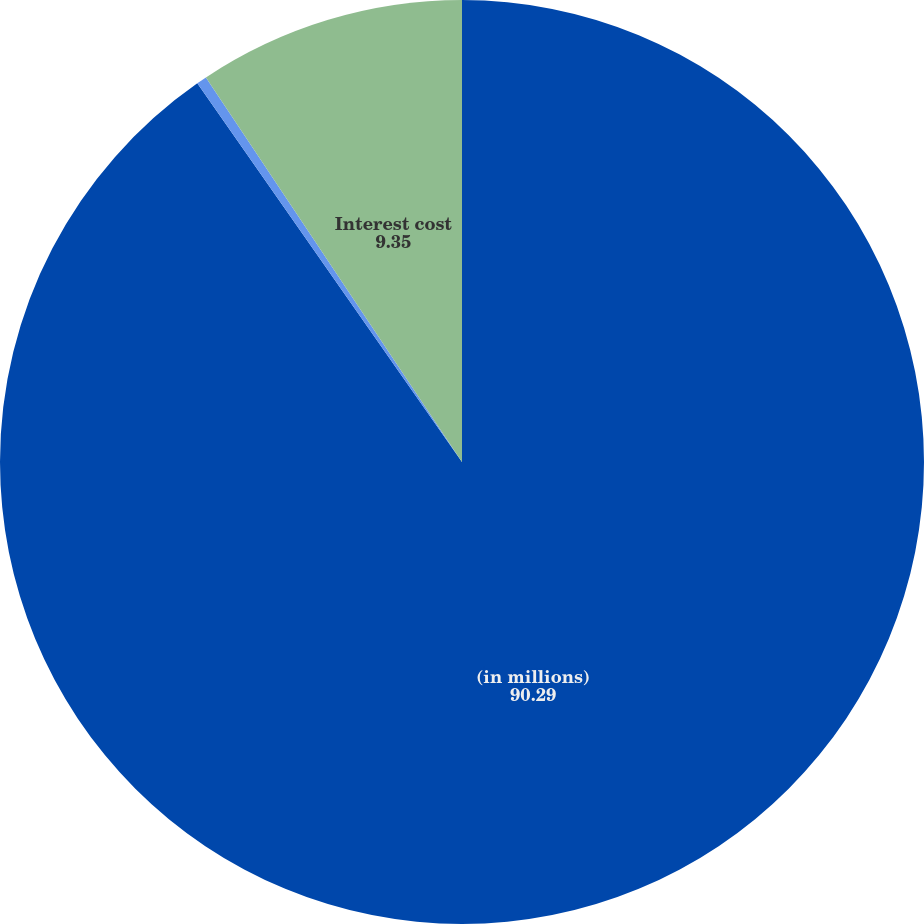<chart> <loc_0><loc_0><loc_500><loc_500><pie_chart><fcel>(in millions)<fcel>Service cost<fcel>Interest cost<nl><fcel>90.29%<fcel>0.36%<fcel>9.35%<nl></chart> 